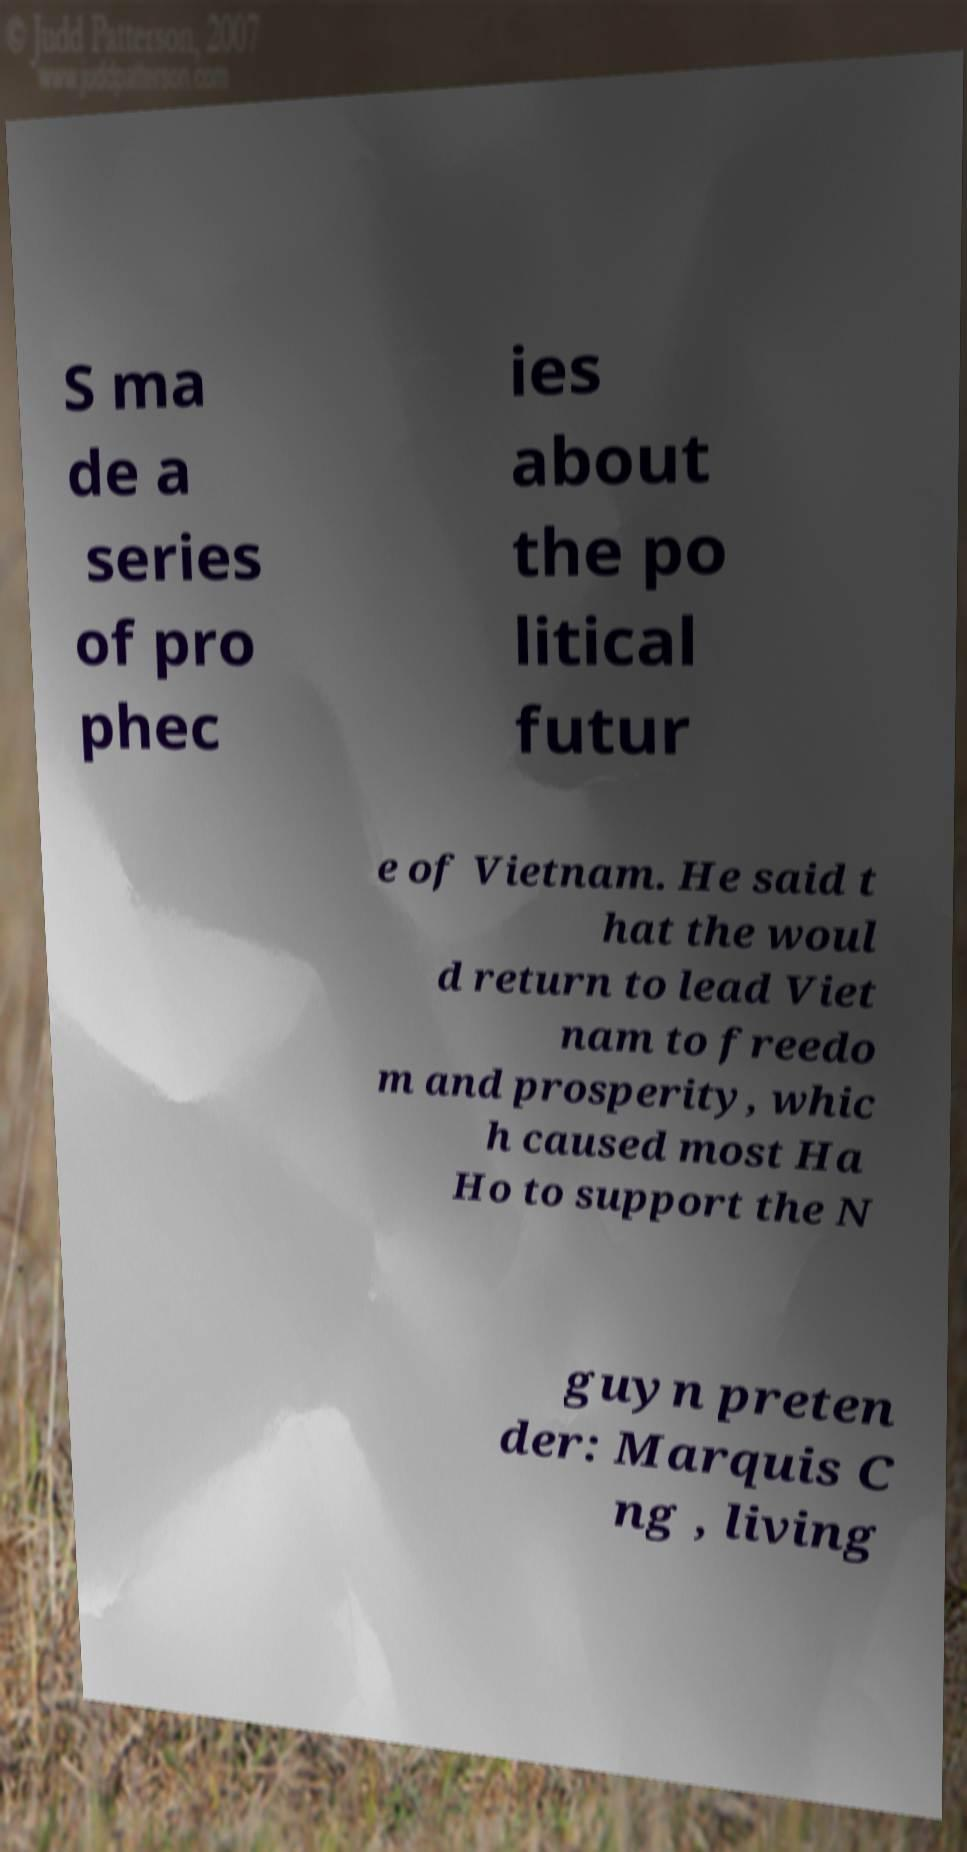Could you extract and type out the text from this image? S ma de a series of pro phec ies about the po litical futur e of Vietnam. He said t hat the woul d return to lead Viet nam to freedo m and prosperity, whic h caused most Ha Ho to support the N guyn preten der: Marquis C ng , living 